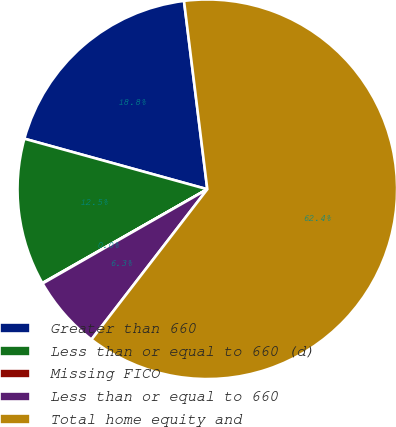Convert chart. <chart><loc_0><loc_0><loc_500><loc_500><pie_chart><fcel>Greater than 660<fcel>Less than or equal to 660 (d)<fcel>Missing FICO<fcel>Less than or equal to 660<fcel>Total home equity and<nl><fcel>18.75%<fcel>12.52%<fcel>0.04%<fcel>6.28%<fcel>62.41%<nl></chart> 